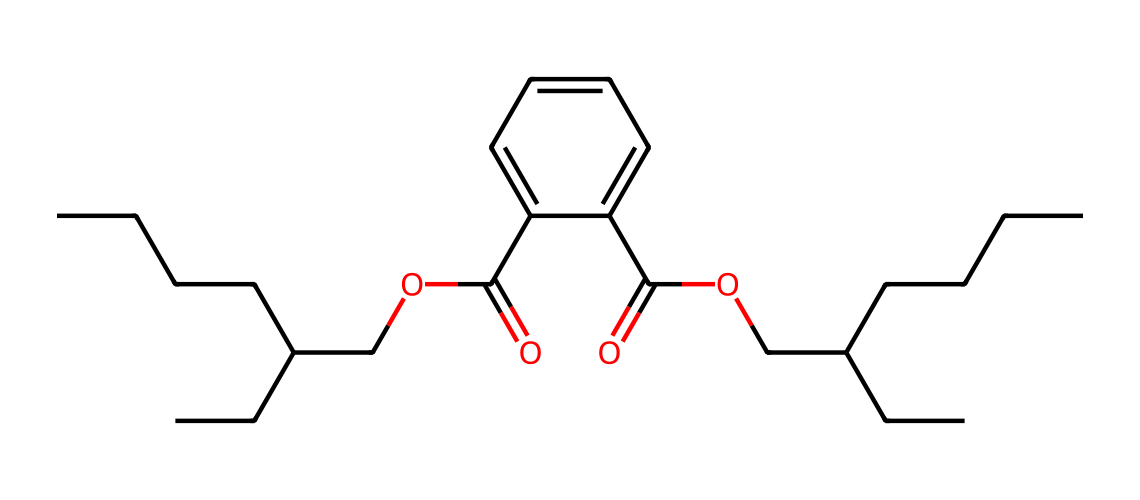What is the parent chain length of this chemical? The parent chain can be identified by counting the continuous carbon atoms in the main chain, which consists of five carbon atoms and a branching point, indicating a total length of eleven carbon atoms.
Answer: eleven How many oxygen atoms are present in this structure? By examining the SMILES representation, we can count the oxygen symbols present, which appears three times in total, indicating the presence of three oxygen atoms in the structure.
Answer: three What functional groups are present in this chemical? Upon analysis of the structure, we can identify two functional groups: an ester (due to the COC and C(=O) connections) and a carboxylic acid (from the presence of -COOH), indicating the presence of both an ester and a carboxylic acid.
Answer: ester and carboxylic acid Is this chemical likely to be hydrophilic or hydrophobic? The presence of multiple carbon chains suggests a higher hydrophobic character, while the carboxylic acid contributes some hydrophilicity; however, the dominating long carbon chains indicate primarily hydrophobic character.
Answer: hydrophobic What types of bonds are present in this molecule? Analyzing the SMILES shows a combination of single (C-C), double (C=O), and possibly ester connections (C-O-C), providing insight into the molecular interactions and bonding types that define this chemical.
Answer: single and double bonds 